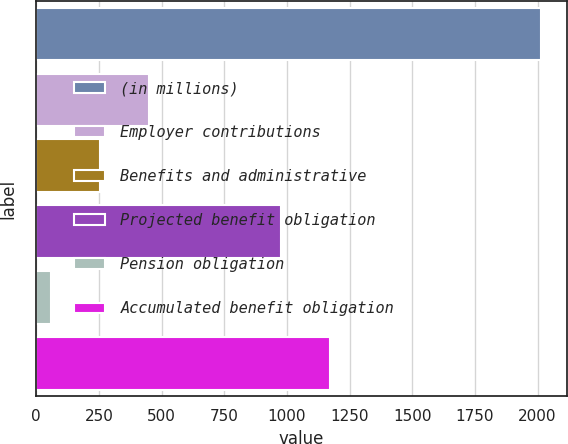<chart> <loc_0><loc_0><loc_500><loc_500><bar_chart><fcel>(in millions)<fcel>Employer contributions<fcel>Benefits and administrative<fcel>Projected benefit obligation<fcel>Pension obligation<fcel>Accumulated benefit obligation<nl><fcel>2015<fcel>451<fcel>255.5<fcel>977<fcel>60<fcel>1172.5<nl></chart> 